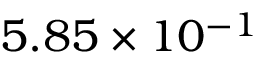Convert formula to latex. <formula><loc_0><loc_0><loc_500><loc_500>5 . 8 5 \times 1 0 ^ { - 1 }</formula> 